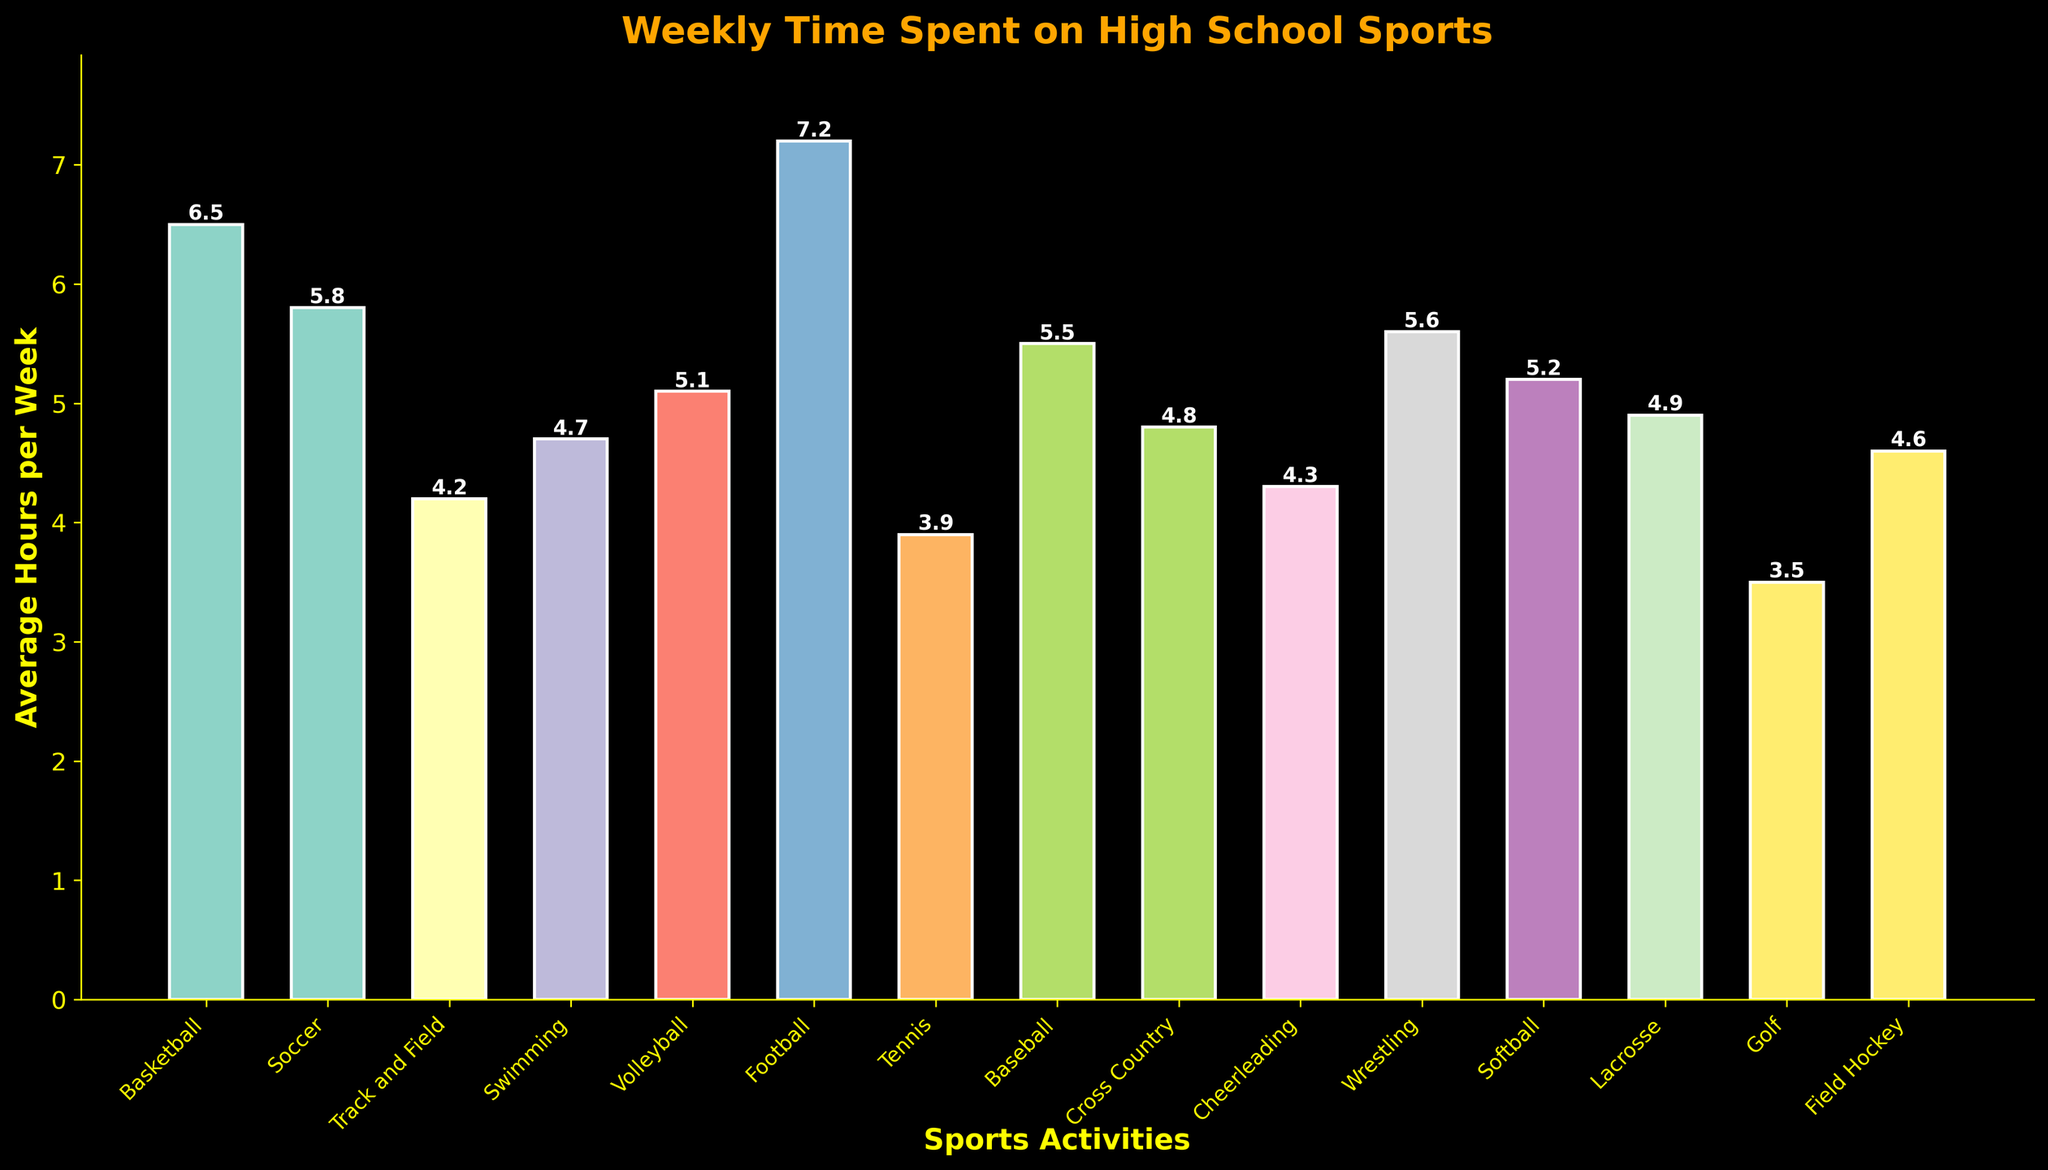Which sport has the highest average weekly hours? The highest bar in the chart represents the sport with the highest average weekly hours. Football has the highest value of 7.2 hours per week.
Answer: Football What is the difference in average weekly hours between Basketball and Soccer? The average hours for Basketball is 6.5, and for Soccer, it's 5.8. The difference, calculated as 6.5 - 5.8, is 0.7 hours.
Answer: 0.7 hours Which sports have average weekly hours greater than 5 but less than 6? By examining the heights of the bars, we can identify that Swimming, Volleyball, Baseball, and Wrestling have values that fall within the range.
Answer: Swimming, Volleyball, Baseball, Wrestling How much more time do Football players spend compared to Tennis players on average weekly? Football players spend 7.2 hours, and Tennis players spend 3.9 hours. The difference is calculated as 7.2 - 3.9, which equals 3.3 hours.
Answer: 3.3 hours What's the average weekly time spent on sports activities across all listed sports? Sum all the average weekly hours: 6.5 + 5.8 + 4.2 + 4.7 + 5.1 + 7.2 + 3.9 + 5.5 + 4.8 + 4.3 + 5.6 + 5.2 + 4.9 + 3.5 + 4.6 = 75.8. Divide by the number of sports, which is 15. So, the average is 75.8 / 15 = 5.05 hours per week.
Answer: 5.05 hours Which sport has the closest average weekly hours to the median value of the dataset? First, list all values in order: 3.5, 3.9, 4.2, 4.3, 4.6, 4.7, 4.8, 4.9, 5.1, 5.2, 5.5, 5.6, 5.8, 6.5, 7.2. The middle value (8th in this case) is 4.9, so Lacrosse has the value closest to the median.
Answer: Lacrosse How many sports have average weekly hours below 5? Count the bars with heights below 5. The sports that meet this condition are Track and Field, Swimming, Tennis, Cheerleading, Lacrosse, Cross Country, Golf, Field Hockey. There are 8 of them.
Answer: 8 sports Which bar is the tallest in the chart, and what does it represent? The tallest bar represents Football, which has the highest average weekly hours of 7.2.
Answer: Football Are there more sports with average weekly hours above or below the average value of the dataset? The average value is 5.05 hours. Counting the number of sports above this value gives us 6 sports (Basketball, Soccer, Volleyball, Football, Baseball, Wrestling) and below gives us 9 sports (Track and Field, Swimming, Tennis, Cheerleading, Lacrosse, Cross Country, Golf, Field Hockey). Therefore, there are more sports below the average value.
Answer: Below 